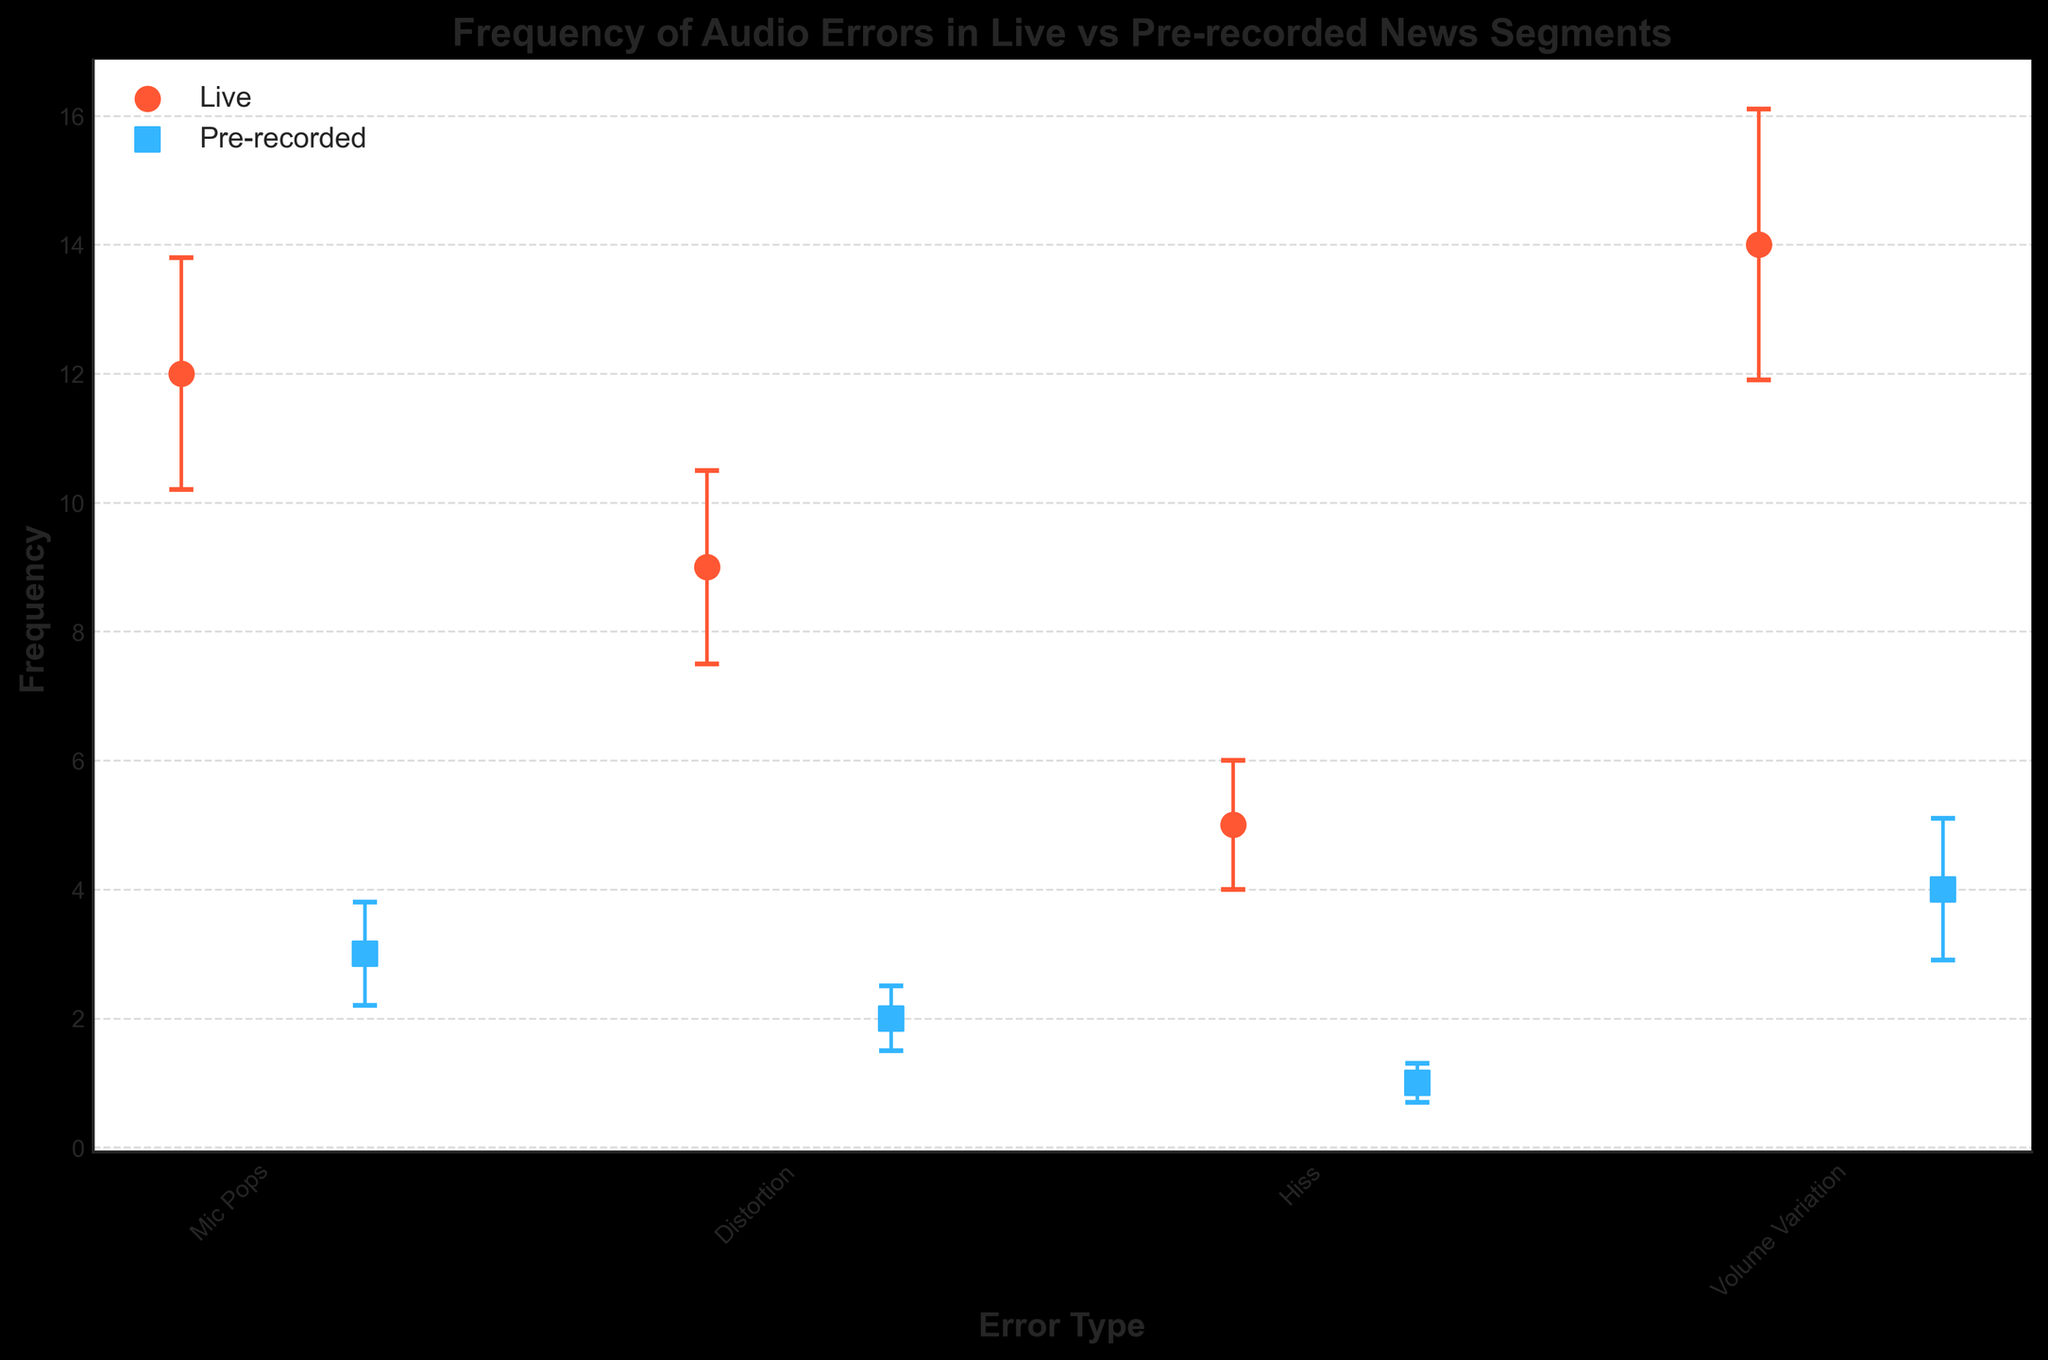What's the title of the figure? The title is displayed at the top center of the figure in bold text.
Answer: Frequency of Audio Errors in Live vs Pre-recorded News Segments What are the two segment types compared in the figure? These can be identified by examining the legend in the figure where two different color markers are labeled.
Answer: Live and Pre-recorded Which error type occurs most frequently in live segments? Look at the y-values of the orange dots representing live segments and identify the highest value.
Answer: Volume Variation How much higher is the frequency of mic pops in live segments compared to pre-recorded segments? Find the y-values for Mic Pops for both Live and Pre-recorded segments, and then calculate the difference between them.
Answer: 9 What are the y-axis units used in the figure? The y-axis units can be inferred from the label of the y-axis.
Answer: Frequency Which segment type has a higher average frequency of errors? Calculate the average frequency for each segment type by summing their frequencies and dividing by the number of error types (4). Average for Live: (12+9+5+14)/4 = 10; Average for Pre-recorded: (3+2+1+4)/4 = 2.5
Answer: Live What is the standard deviation for volume variation errors in pre-recorded segments? Identify the value adjacent to 'Volume Variation' for pre-recorded from the error bars lines.
Answer: 1.1 Which error type has the smallest difference in frequency between live and pre-recorded segments? Calculate the differences for each error type: 
- Mic Pops: 12-3 = 9 
- Distortion: 9-2 = 7 
- Hiss: 5-1 = 4 
- Volume Variation: 14-4 = 10 
Identify the smallest value.
Answer: Hiss What is the segment type that has fewer errors overall? Calculate the total frequencies for each segment type by summing all errors for Live and Pre-recorded segments. Total for Live: 12+9+5+14 = 40; Total for Pre-recorded: 3+2+1+4 = 10
Answer: Pre-recorded How many error types have a frequency of less than 10 in live segments? Count the number of error types where the y-values of the corresponding live segment are below 10.
Answer: 2 